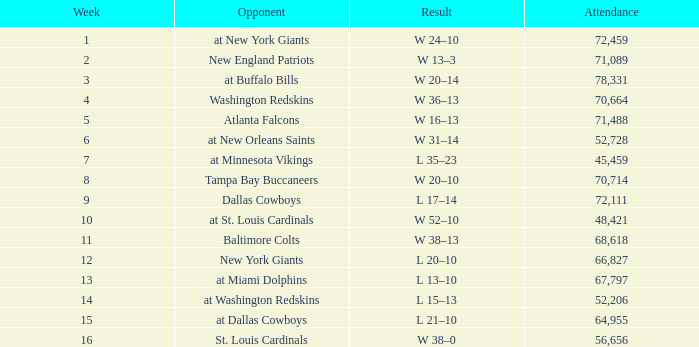What is the average Attendance, when the Date is September 17, 1981? 78331.0. 